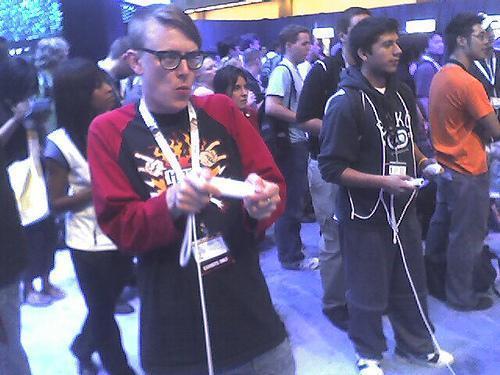How many people can you see?
Give a very brief answer. 7. 